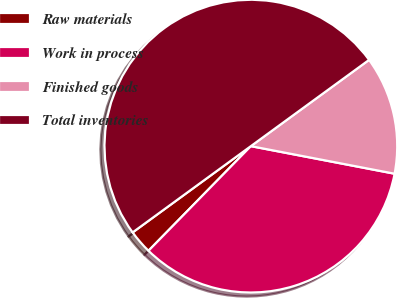<chart> <loc_0><loc_0><loc_500><loc_500><pie_chart><fcel>Raw materials<fcel>Work in process<fcel>Finished goods<fcel>Total inventories<nl><fcel>2.64%<fcel>34.31%<fcel>13.05%<fcel>50.0%<nl></chart> 